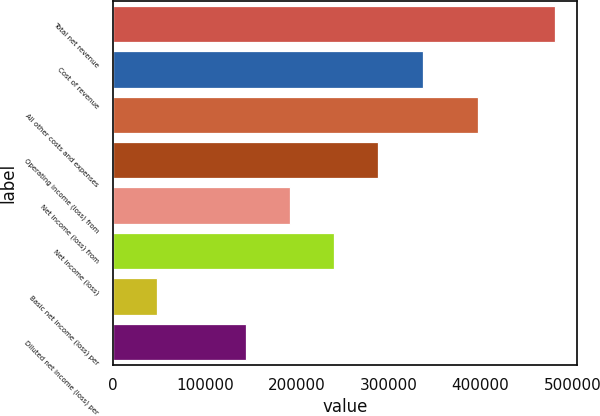Convert chart to OTSL. <chart><loc_0><loc_0><loc_500><loc_500><bar_chart><fcel>Total net revenue<fcel>Cost of revenue<fcel>All other costs and expenses<fcel>Operating income (loss) from<fcel>Net income (loss) from<fcel>Net income (loss)<fcel>Basic net income (loss) per<fcel>Diluted net income (loss) per<nl><fcel>481379<fcel>336965<fcel>397088<fcel>288827<fcel>192552<fcel>240690<fcel>48138<fcel>144414<nl></chart> 